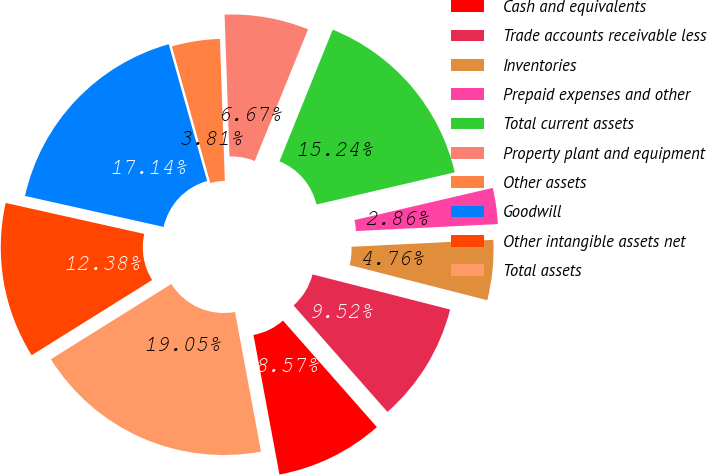Convert chart to OTSL. <chart><loc_0><loc_0><loc_500><loc_500><pie_chart><fcel>Cash and equivalents<fcel>Trade accounts receivable less<fcel>Inventories<fcel>Prepaid expenses and other<fcel>Total current assets<fcel>Property plant and equipment<fcel>Other assets<fcel>Goodwill<fcel>Other intangible assets net<fcel>Total assets<nl><fcel>8.57%<fcel>9.52%<fcel>4.76%<fcel>2.86%<fcel>15.24%<fcel>6.67%<fcel>3.81%<fcel>17.14%<fcel>12.38%<fcel>19.05%<nl></chart> 